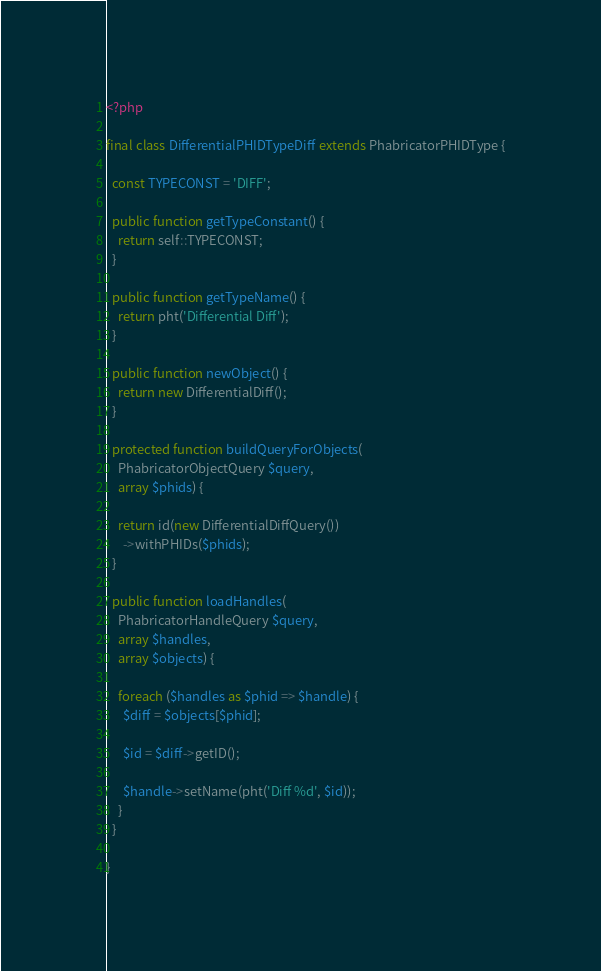<code> <loc_0><loc_0><loc_500><loc_500><_PHP_><?php

final class DifferentialPHIDTypeDiff extends PhabricatorPHIDType {

  const TYPECONST = 'DIFF';

  public function getTypeConstant() {
    return self::TYPECONST;
  }

  public function getTypeName() {
    return pht('Differential Diff');
  }

  public function newObject() {
    return new DifferentialDiff();
  }

  protected function buildQueryForObjects(
    PhabricatorObjectQuery $query,
    array $phids) {

    return id(new DifferentialDiffQuery())
      ->withPHIDs($phids);
  }

  public function loadHandles(
    PhabricatorHandleQuery $query,
    array $handles,
    array $objects) {

    foreach ($handles as $phid => $handle) {
      $diff = $objects[$phid];

      $id = $diff->getID();

      $handle->setName(pht('Diff %d', $id));
    }
  }

}
</code> 